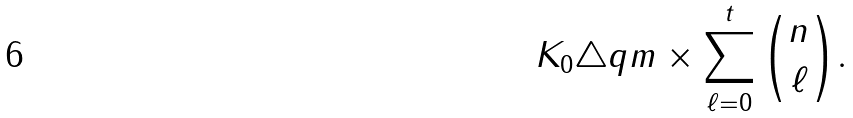<formula> <loc_0><loc_0><loc_500><loc_500>K _ { 0 } \triangle q m \times \sum _ { \ell = 0 } ^ { t } { \binom { n } { \ell } } .</formula> 